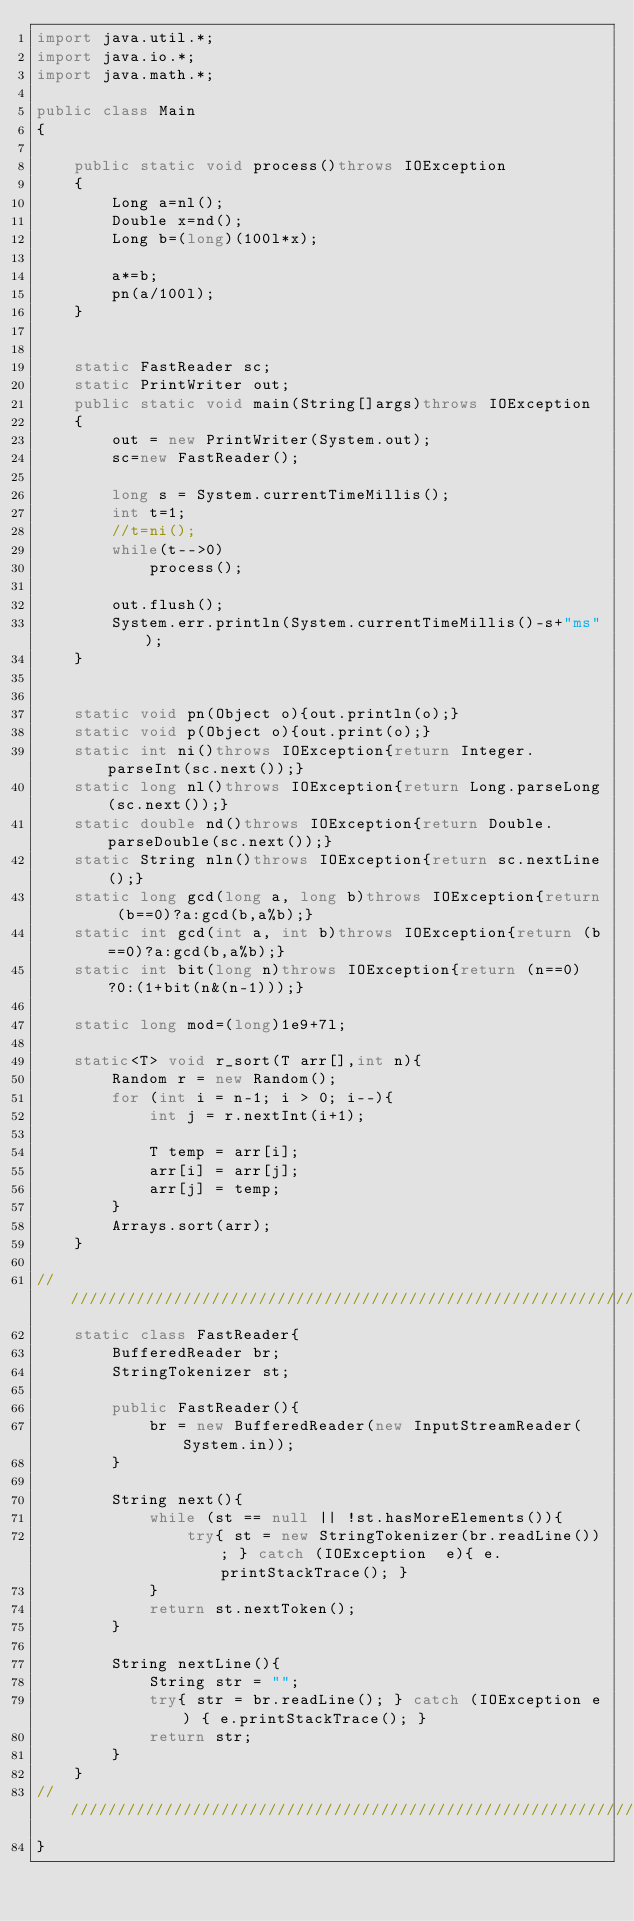Convert code to text. <code><loc_0><loc_0><loc_500><loc_500><_Java_>import java.util.*;
import java.io.*;
import java.math.*;

public class Main
{

    public static void process()throws IOException
    {
        Long a=nl();
        Double x=nd();
        Long b=(long)(100l*x);

        a*=b;
        pn(a/100l);
    }


    static FastReader sc;
    static PrintWriter out;
    public static void main(String[]args)throws IOException
    {
        out = new PrintWriter(System.out);
        sc=new FastReader();

        long s = System.currentTimeMillis();
        int t=1;
        //t=ni();
        while(t-->0)
            process();

        out.flush();
        System.err.println(System.currentTimeMillis()-s+"ms");
    }
    
    
    static void pn(Object o){out.println(o);}
    static void p(Object o){out.print(o);}
    static int ni()throws IOException{return Integer.parseInt(sc.next());}
    static long nl()throws IOException{return Long.parseLong(sc.next());}
    static double nd()throws IOException{return Double.parseDouble(sc.next());}
    static String nln()throws IOException{return sc.nextLine();}
    static long gcd(long a, long b)throws IOException{return (b==0)?a:gcd(b,a%b);}
    static int gcd(int a, int b)throws IOException{return (b==0)?a:gcd(b,a%b);}
    static int bit(long n)throws IOException{return (n==0)?0:(1+bit(n&(n-1)));}
    
    static long mod=(long)1e9+7l;

    static<T> void r_sort(T arr[],int n){
        Random r = new Random(); 
        for (int i = n-1; i > 0; i--){ 
            int j = r.nextInt(i+1); 
                  
            T temp = arr[i]; 
            arr[i] = arr[j]; 
            arr[j] = temp; 
        } 
        Arrays.sort(arr); 
    }
    
/////////////////////////////////////////////////////////////////////////////////////////////////////////
    static class FastReader{ 
        BufferedReader br; 
        StringTokenizer st; 
  
        public FastReader(){ 
            br = new BufferedReader(new InputStreamReader(System.in)); 
        } 
  
        String next(){ 
            while (st == null || !st.hasMoreElements()){ 
                try{ st = new StringTokenizer(br.readLine()); } catch (IOException  e){ e.printStackTrace(); } 
            } 
            return st.nextToken(); 
        } 
  
        String nextLine(){ 
            String str = ""; 
            try{ str = br.readLine(); } catch (IOException e) { e.printStackTrace(); } 
            return str; 
        } 
    } 
/////////////////////////////////////////////////////////////////////////////////////////////////////////////
}
</code> 